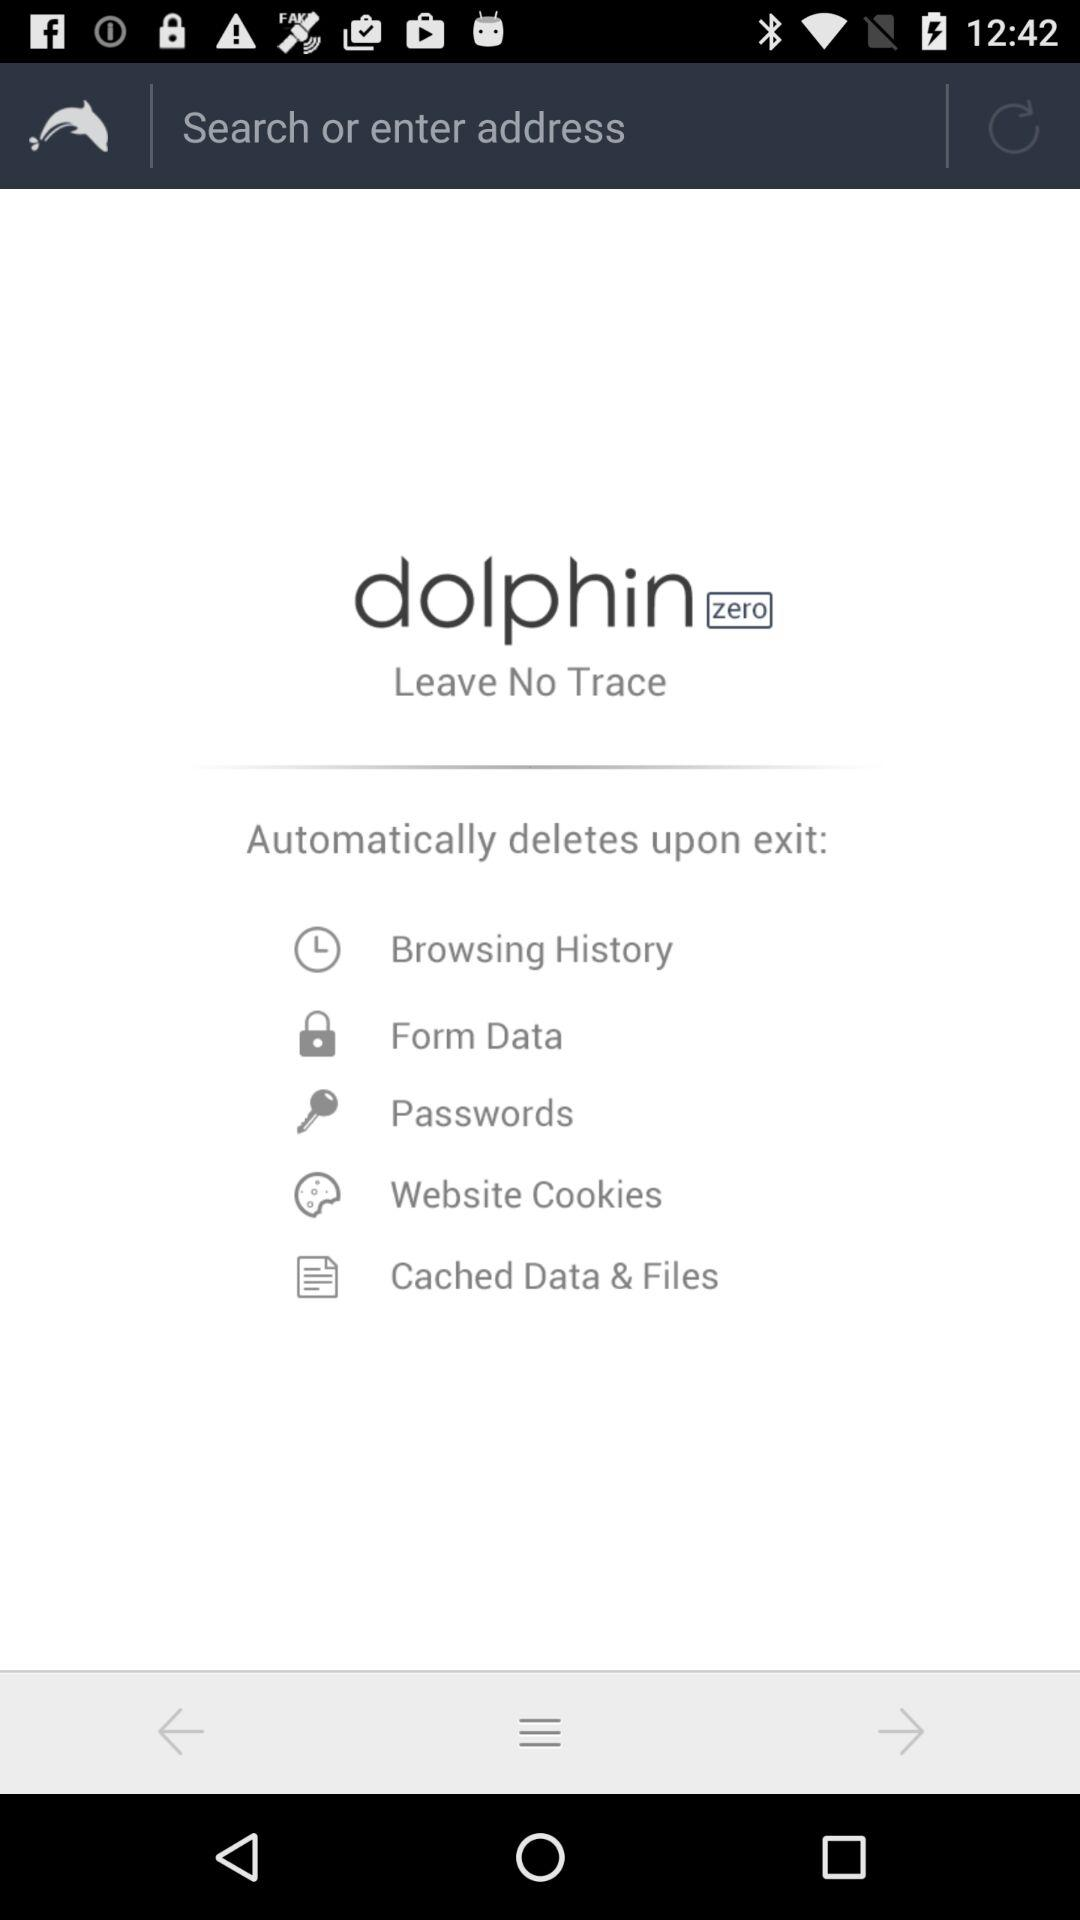What is the application name? The application name is "dolphin zero". 